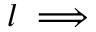<formula> <loc_0><loc_0><loc_500><loc_500>l \implies</formula> 